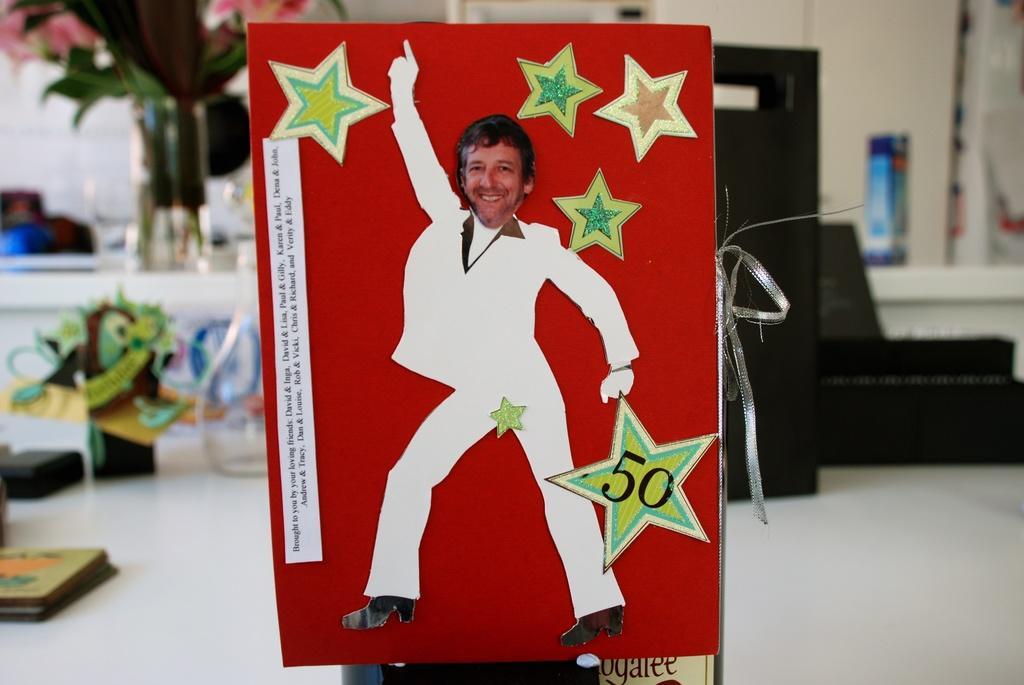Can you describe this image briefly? In this image there is a red color object which has a picture of a person dancing and there are some other objects in the background. 